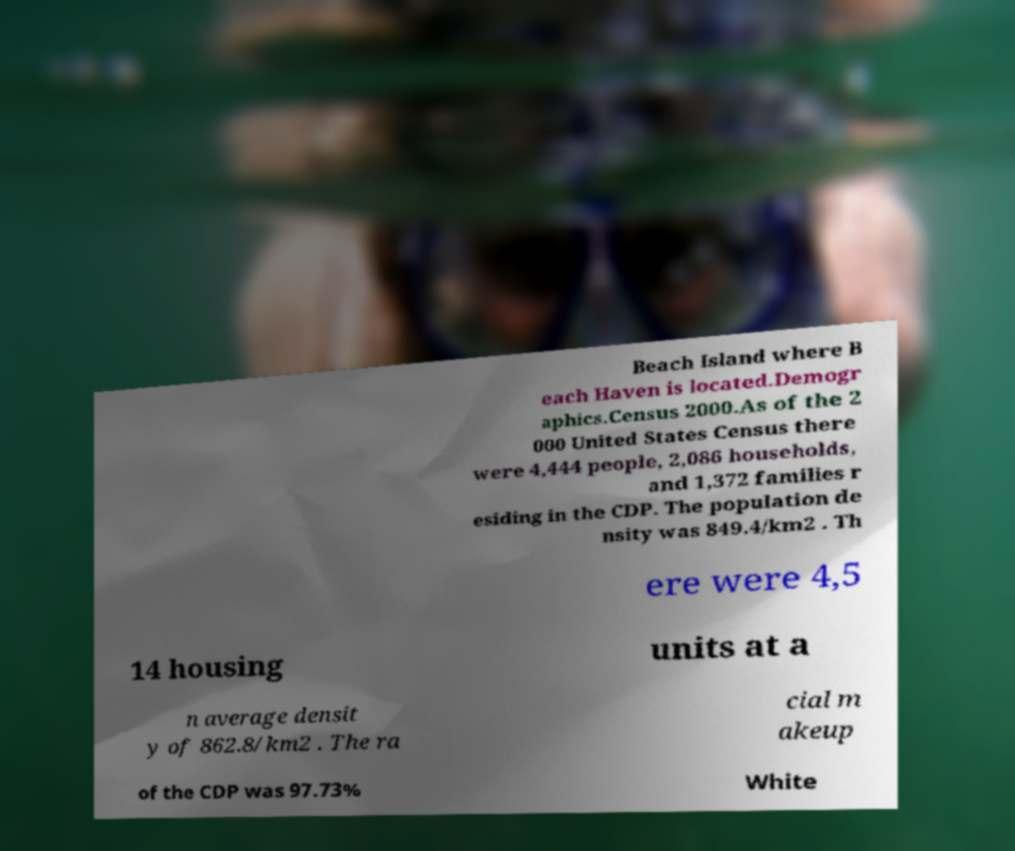Please read and relay the text visible in this image. What does it say? Beach Island where B each Haven is located.Demogr aphics.Census 2000.As of the 2 000 United States Census there were 4,444 people, 2,086 households, and 1,372 families r esiding in the CDP. The population de nsity was 849.4/km2 . Th ere were 4,5 14 housing units at a n average densit y of 862.8/km2 . The ra cial m akeup of the CDP was 97.73% White 